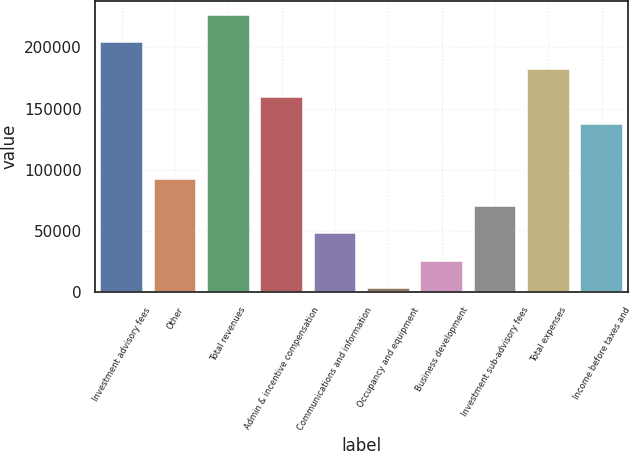Convert chart. <chart><loc_0><loc_0><loc_500><loc_500><bar_chart><fcel>Investment advisory fees<fcel>Other<fcel>Total revenues<fcel>Admin & incentive compensation<fcel>Communications and information<fcel>Occupancy and equipment<fcel>Business development<fcel>Investment sub-advisory fees<fcel>Total expenses<fcel>Income before taxes and<nl><fcel>204227<fcel>92806.4<fcel>226511<fcel>159659<fcel>48238.2<fcel>3670<fcel>25954.1<fcel>70522.3<fcel>181943<fcel>137375<nl></chart> 